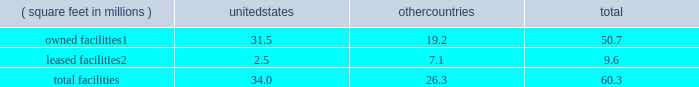There are inherent limitations on the effectiveness of our controls .
We do not expect that our disclosure controls or our internal control over financial reporting will prevent or detect all errors and all fraud .
A control system , no matter how well-designed and operated , can provide only reasonable , not absolute , assurance that the control system 2019s objectives will be met .
The design of a control system must reflect the fact that resource constraints exist , and the benefits of controls must be considered relative to their costs .
Further , because of the inherent limitations in all control systems , no evaluation of controls can provide absolute assurance that misstatements due to error or fraud will not occur or that all control issues and instances of fraud , if any , have been detected .
The design of any system of controls is based in part on certain assumptions about the likelihood of future events , and there can be no assurance that any design will succeed in achieving its stated goals under all potential future conditions .
Projections of any evaluation of the effectiveness of controls to future periods are subject to risks .
Over time , controls may become inadequate due to changes in conditions or deterioration in the degree of compliance with policies or procedures .
If our controls become inadequate , we could fail to meet our financial reporting obligations , our reputation may be adversely affected , our business and operating results could be harmed , and the market price of our stock could decline .
Item 1b .
Unresolved staff comments not applicable .
Item 2 .
Properties as of december 31 , 2016 , our major facilities consisted of : ( square feet in millions ) united states countries total owned facilities1 .
31.5 19.2 50.7 leased facilities2 .
2.5 7.1 9.6 .
1 leases and municipal grants on portions of the land used for these facilities expire on varying dates through 2109 .
2 leases expire on varying dates through 2058 and generally include renewals at our option .
Our principal executive offices are located in the u.s .
And the majority of our wafer manufacturing activities in 2016 were also located in the u.s .
One of our arizona wafer fabrication facilities is currently on hold and held in a safe state , and we are reserving the building for additional capacity and future technologies .
Incremental construction and equipment installation are required to ready the facility for its intended use .
For more information on our wafer fabrication and our assembly and test facilities , see 201cmanufacturing and assembly and test 201d in part i , item 1 of this form 10-k .
We believe that the facilities described above are suitable and adequate for our present purposes and that the productive capacity in our facilities is substantially being utilized or we have plans to utilize it .
We do not identify or allocate assets by operating segment .
For information on net property , plant and equipment by country , see 201cnote 4 : operating segments and geographic information 201d in part ii , item 8 of this form 10-k .
Item 3 .
Legal proceedings for a discussion of legal proceedings , see 201cnote 20 : commitments and contingencies 201d in part ii , item 8 of this form 10-k .
Item 4 .
Mine safety disclosures not applicable. .
As of december 31 , 2016 what percentage by square feet of major facilities are located in the united states? 
Computations: (34.0 / 60.3)
Answer: 0.56385. 